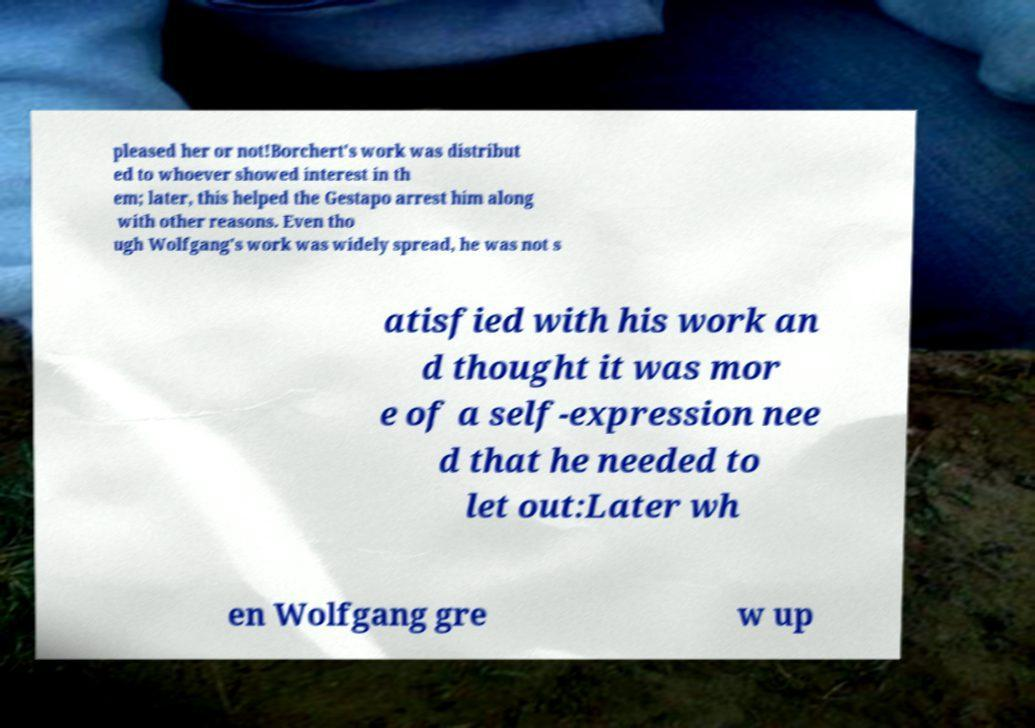Can you read and provide the text displayed in the image?This photo seems to have some interesting text. Can you extract and type it out for me? pleased her or not!Borchert's work was distribut ed to whoever showed interest in th em; later, this helped the Gestapo arrest him along with other reasons. Even tho ugh Wolfgang's work was widely spread, he was not s atisfied with his work an d thought it was mor e of a self-expression nee d that he needed to let out:Later wh en Wolfgang gre w up 